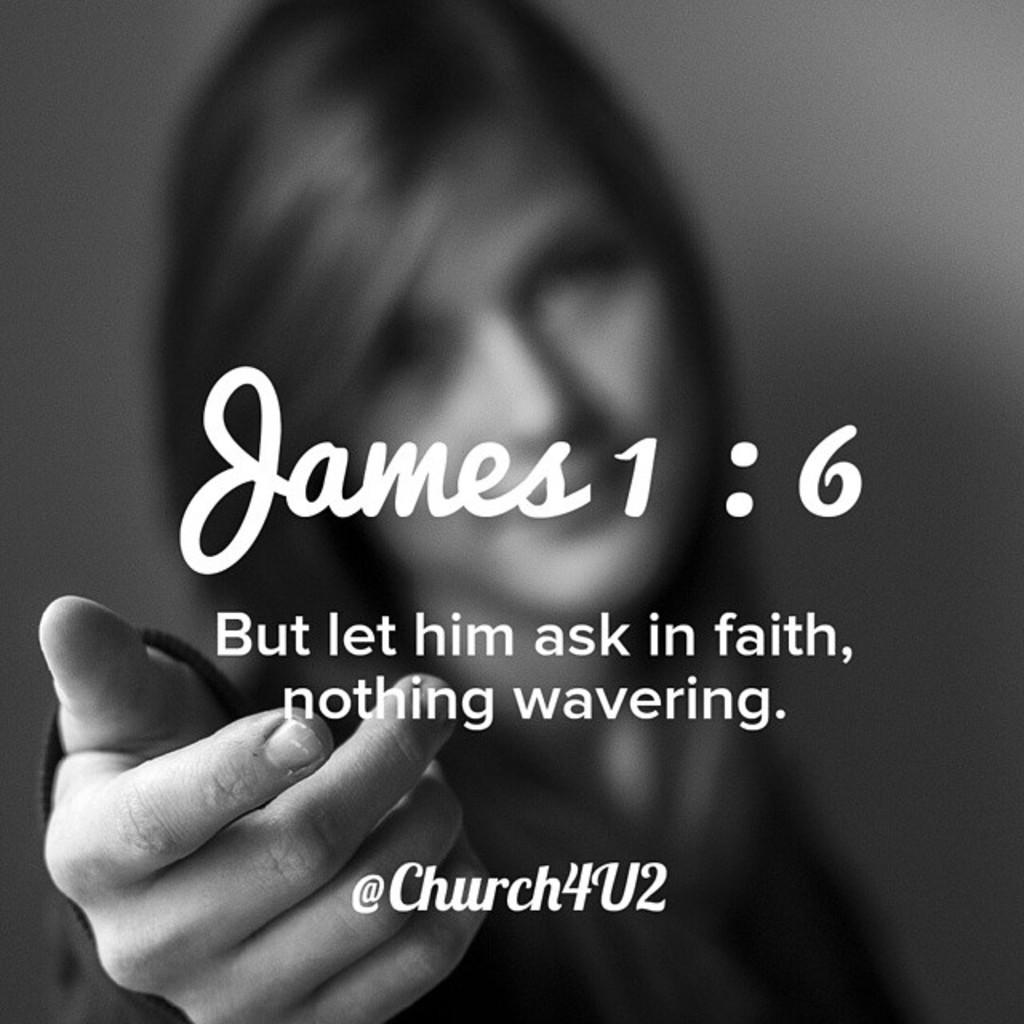What is the color scheme of the poster in the image? The poster is black and white. What is the main subject of the poster? There is a person depicted on the poster. What else is featured on the poster besides the image? There is text on the poster. Can you tell me how many goldfish are swimming in the background of the poster? There are no goldfish present in the image, as the poster is black and white and features a person and text. What time of day is depicted in the poster? The time of day is not mentioned or depicted in the poster, as it only features a person, text, and a black and white color scheme. 